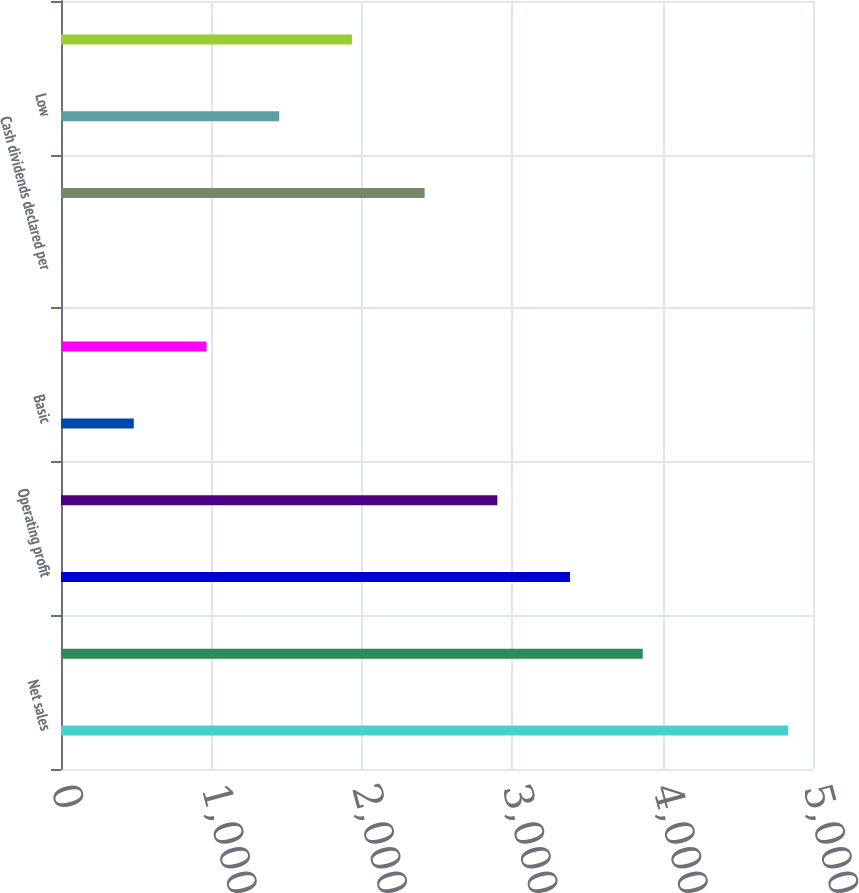Convert chart to OTSL. <chart><loc_0><loc_0><loc_500><loc_500><bar_chart><fcel>Net sales<fcel>Gross profit<fcel>Operating profit<fcel>Corporation<fcel>Basic<fcel>Diluted<fcel>Cash dividends declared per<fcel>High<fcel>Low<fcel>Close<nl><fcel>4835<fcel>3868.1<fcel>3384.67<fcel>2901.24<fcel>484.09<fcel>967.52<fcel>0.66<fcel>2417.81<fcel>1450.95<fcel>1934.38<nl></chart> 